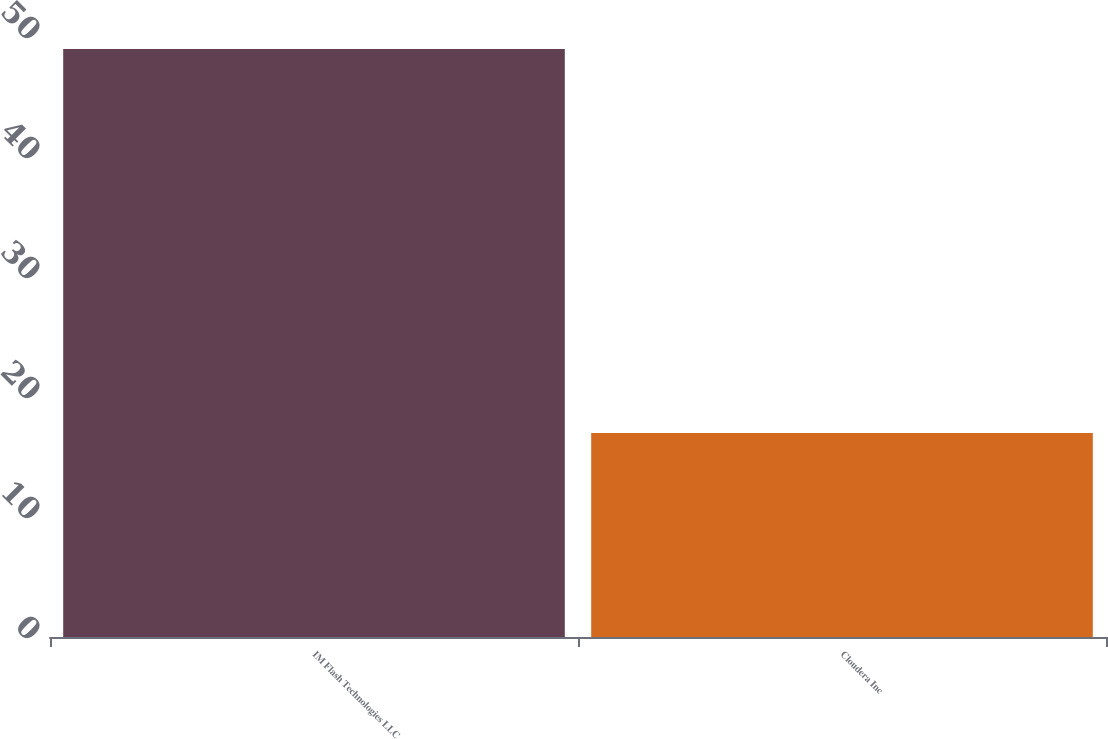Convert chart. <chart><loc_0><loc_0><loc_500><loc_500><bar_chart><fcel>IM Flash Technologies LLC<fcel>Cloudera Inc<nl><fcel>49<fcel>17<nl></chart> 